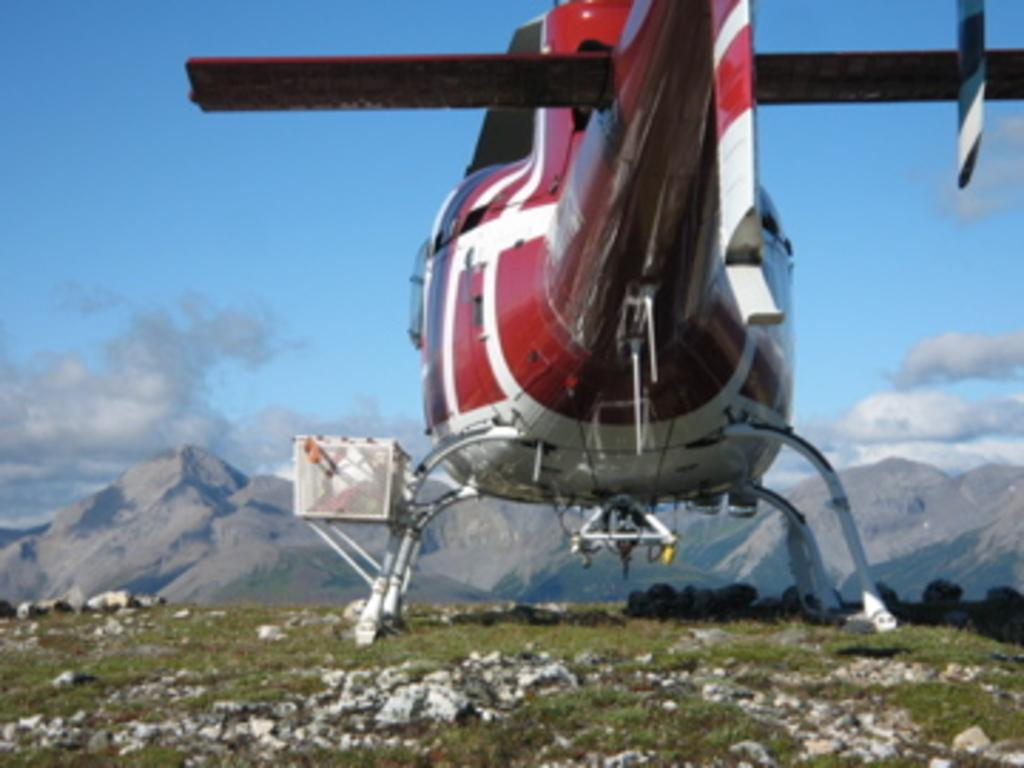What is the main subject of the image? The main subject of the image is an aircraft. What colors are used to paint the aircraft? The aircraft is in red and white color. What can be seen in the background of the image? There are mountains in the background of the image. What is the color of the sky in the image? The sky is in blue and white color. What type of coat is the aircraft wearing in the image? Aircrafts do not wear coats; they are inanimate objects. The image shows an aircraft in red and white color, but there is no coat mentioned or visible. 